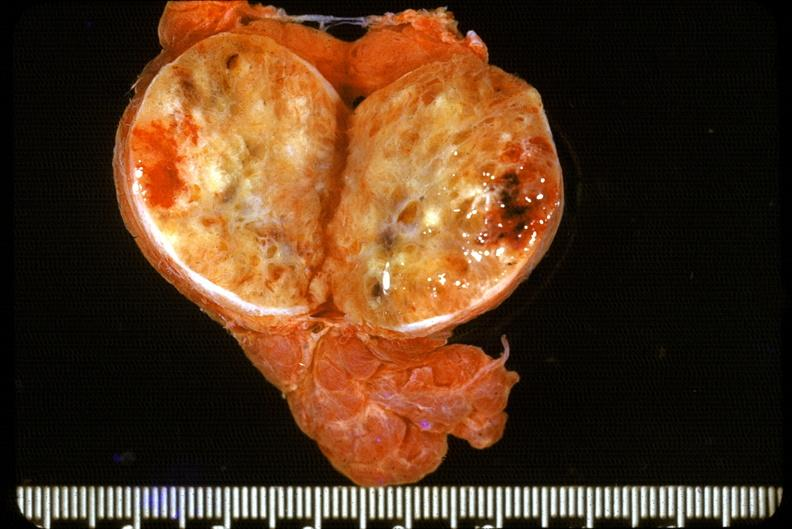s endocrine present?
Answer the question using a single word or phrase. Yes 